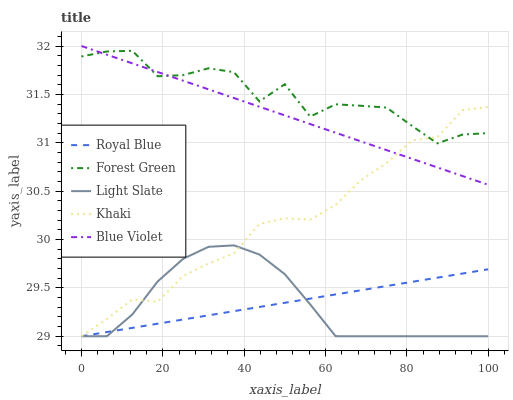Does Light Slate have the minimum area under the curve?
Answer yes or no. Yes. Does Forest Green have the maximum area under the curve?
Answer yes or no. Yes. Does Royal Blue have the minimum area under the curve?
Answer yes or no. No. Does Royal Blue have the maximum area under the curve?
Answer yes or no. No. Is Royal Blue the smoothest?
Answer yes or no. Yes. Is Forest Green the roughest?
Answer yes or no. Yes. Is Forest Green the smoothest?
Answer yes or no. No. Is Royal Blue the roughest?
Answer yes or no. No. Does Light Slate have the lowest value?
Answer yes or no. Yes. Does Forest Green have the lowest value?
Answer yes or no. No. Does Blue Violet have the highest value?
Answer yes or no. Yes. Does Forest Green have the highest value?
Answer yes or no. No. Is Light Slate less than Blue Violet?
Answer yes or no. Yes. Is Blue Violet greater than Royal Blue?
Answer yes or no. Yes. Does Khaki intersect Blue Violet?
Answer yes or no. Yes. Is Khaki less than Blue Violet?
Answer yes or no. No. Is Khaki greater than Blue Violet?
Answer yes or no. No. Does Light Slate intersect Blue Violet?
Answer yes or no. No. 